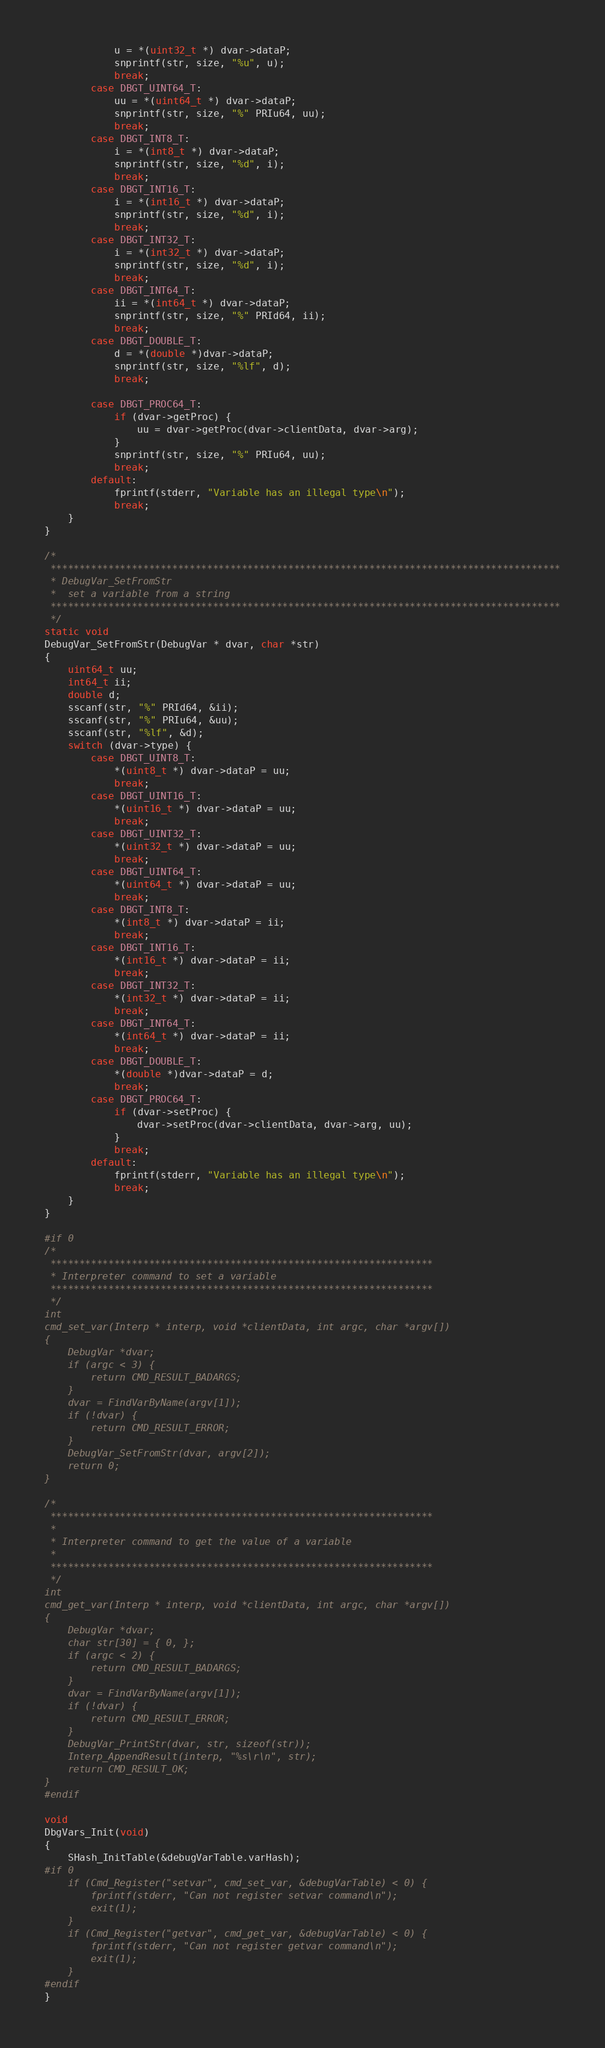Convert code to text. <code><loc_0><loc_0><loc_500><loc_500><_C_>		    u = *(uint32_t *) dvar->dataP;
		    snprintf(str, size, "%u", u);
		    break;
	    case DBGT_UINT64_T:
		    uu = *(uint64_t *) dvar->dataP;
		    snprintf(str, size, "%" PRIu64, uu);
		    break;
	    case DBGT_INT8_T:
		    i = *(int8_t *) dvar->dataP;
		    snprintf(str, size, "%d", i);
		    break;
	    case DBGT_INT16_T:
		    i = *(int16_t *) dvar->dataP;
		    snprintf(str, size, "%d", i);
		    break;
	    case DBGT_INT32_T:
		    i = *(int32_t *) dvar->dataP;
		    snprintf(str, size, "%d", i);
		    break;
	    case DBGT_INT64_T:
		    ii = *(int64_t *) dvar->dataP;
		    snprintf(str, size, "%" PRId64, ii);
		    break;
	    case DBGT_DOUBLE_T:
		    d = *(double *)dvar->dataP;
		    snprintf(str, size, "%lf", d);
		    break;

	    case DBGT_PROC64_T:
		    if (dvar->getProc) {
			    uu = dvar->getProc(dvar->clientData, dvar->arg);
		    }
		    snprintf(str, size, "%" PRIu64, uu);
		    break;
	    default:
		    fprintf(stderr, "Variable has an illegal type\n");
		    break;
	}
}

/*
 ****************************************************************************************
 * DebugVar_SetFromStr
 * 	set a variable from a string
 ****************************************************************************************
 */
static void
DebugVar_SetFromStr(DebugVar * dvar, char *str)
{
	uint64_t uu;
	int64_t ii;
	double d;
	sscanf(str, "%" PRId64, &ii);
	sscanf(str, "%" PRIu64, &uu);
	sscanf(str, "%lf", &d);
	switch (dvar->type) {
	    case DBGT_UINT8_T:
		    *(uint8_t *) dvar->dataP = uu;
		    break;
	    case DBGT_UINT16_T:
		    *(uint16_t *) dvar->dataP = uu;
		    break;
	    case DBGT_UINT32_T:
		    *(uint32_t *) dvar->dataP = uu;
		    break;
	    case DBGT_UINT64_T:
		    *(uint64_t *) dvar->dataP = uu;
		    break;
	    case DBGT_INT8_T:
		    *(int8_t *) dvar->dataP = ii;
		    break;
	    case DBGT_INT16_T:
		    *(int16_t *) dvar->dataP = ii;
		    break;
	    case DBGT_INT32_T:
		    *(int32_t *) dvar->dataP = ii;
		    break;
	    case DBGT_INT64_T:
		    *(int64_t *) dvar->dataP = ii;
		    break;
	    case DBGT_DOUBLE_T:
		    *(double *)dvar->dataP = d;
		    break;
	    case DBGT_PROC64_T:
		    if (dvar->setProc) {
			    dvar->setProc(dvar->clientData, dvar->arg, uu);
		    }
		    break;
	    default:
		    fprintf(stderr, "Variable has an illegal type\n");
		    break;
	}
}

#if 0
/*
 ******************************************************************
 * Interpreter command to set a variable
 ******************************************************************
 */
int
cmd_set_var(Interp * interp, void *clientData, int argc, char *argv[])
{
	DebugVar *dvar;
	if (argc < 3) {
		return CMD_RESULT_BADARGS;
	}
	dvar = FindVarByName(argv[1]);
	if (!dvar) {
		return CMD_RESULT_ERROR;
	}
	DebugVar_SetFromStr(dvar, argv[2]);
	return 0;
}

/*
 ******************************************************************
 *
 * Interpreter command to get the value of a variable
 *
 ******************************************************************
 */
int
cmd_get_var(Interp * interp, void *clientData, int argc, char *argv[])
{
	DebugVar *dvar;
	char str[30] = { 0, };
	if (argc < 2) {
		return CMD_RESULT_BADARGS;
	}
	dvar = FindVarByName(argv[1]);
	if (!dvar) {
		return CMD_RESULT_ERROR;
	}
	DebugVar_PrintStr(dvar, str, sizeof(str));
	Interp_AppendResult(interp, "%s\r\n", str);
	return CMD_RESULT_OK;
}
#endif

void
DbgVars_Init(void)
{
	SHash_InitTable(&debugVarTable.varHash);
#if 0
	if (Cmd_Register("setvar", cmd_set_var, &debugVarTable) < 0) {
		fprintf(stderr, "Can not register setvar command\n");
		exit(1);
	}
	if (Cmd_Register("getvar", cmd_get_var, &debugVarTable) < 0) {
		fprintf(stderr, "Can not register getvar command\n");
		exit(1);
	}
#endif
}
</code> 